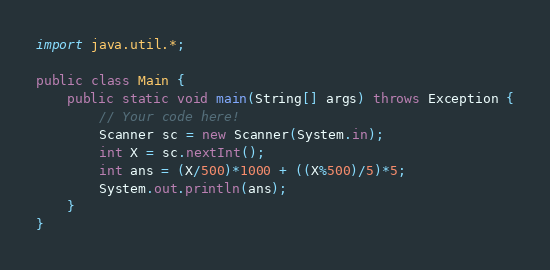Convert code to text. <code><loc_0><loc_0><loc_500><loc_500><_Java_>import java.util.*;

public class Main {
    public static void main(String[] args) throws Exception {
        // Your code here!
        Scanner sc = new Scanner(System.in);
        int X = sc.nextInt();
        int ans = (X/500)*1000 + ((X%500)/5)*5;
        System.out.println(ans);
    }
}
</code> 